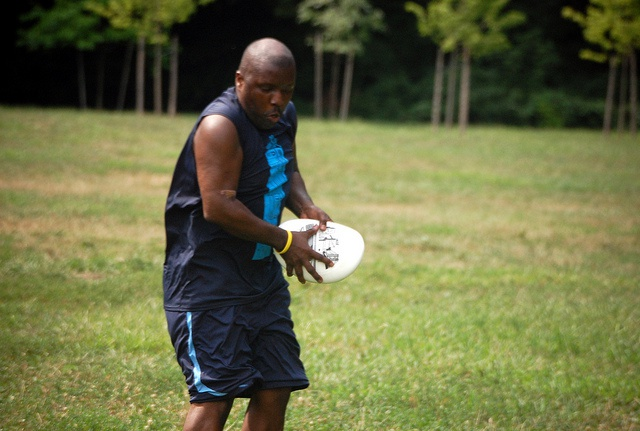Describe the objects in this image and their specific colors. I can see people in black, maroon, gray, and navy tones in this image. 